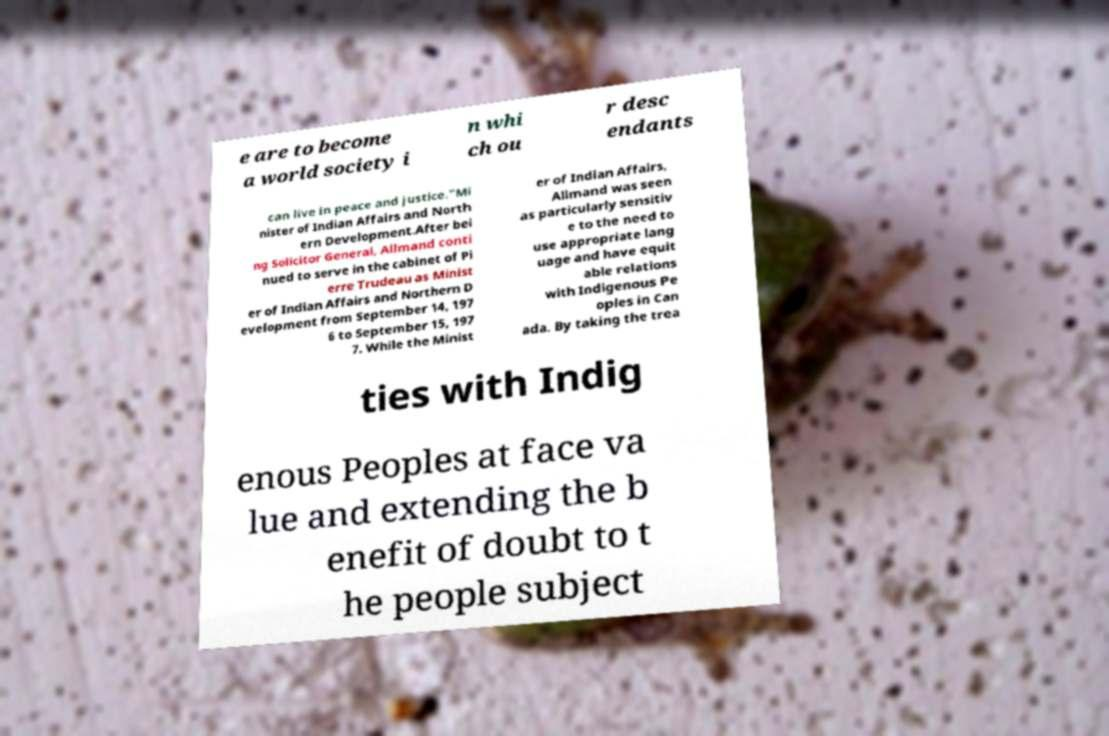Please identify and transcribe the text found in this image. e are to become a world society i n whi ch ou r desc endants can live in peace and justice."Mi nister of Indian Affairs and North ern Development.After bei ng Solicitor General, Allmand conti nued to serve in the cabinet of Pi erre Trudeau as Minist er of Indian Affairs and Northern D evelopment from September 14, 197 6 to September 15, 197 7. While the Minist er of Indian Affairs, Allmand was seen as particularly sensitiv e to the need to use appropriate lang uage and have equit able relations with Indigenous Pe oples in Can ada. By taking the trea ties with Indig enous Peoples at face va lue and extending the b enefit of doubt to t he people subject 